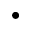<formula> <loc_0><loc_0><loc_500><loc_500>\bullet</formula> 